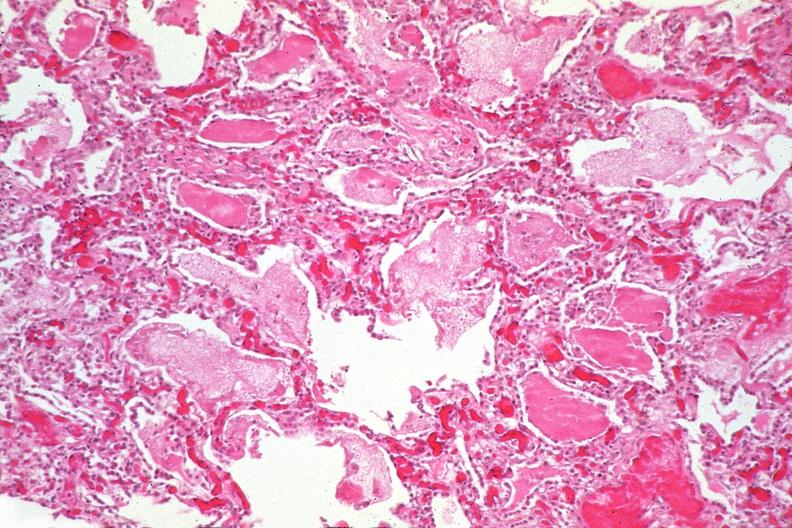does this image show lung, pneumocystis pneumonia?
Answer the question using a single word or phrase. Yes 